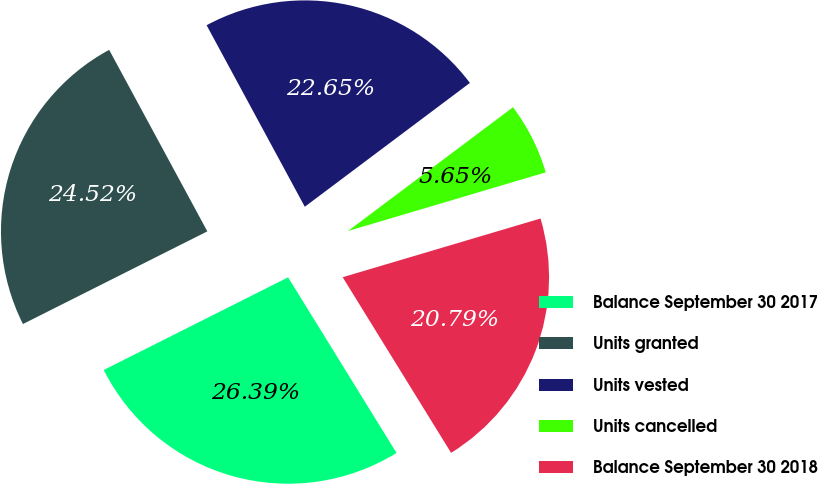Convert chart to OTSL. <chart><loc_0><loc_0><loc_500><loc_500><pie_chart><fcel>Balance September 30 2017<fcel>Units granted<fcel>Units vested<fcel>Units cancelled<fcel>Balance September 30 2018<nl><fcel>26.39%<fcel>24.52%<fcel>22.65%<fcel>5.65%<fcel>20.79%<nl></chart> 